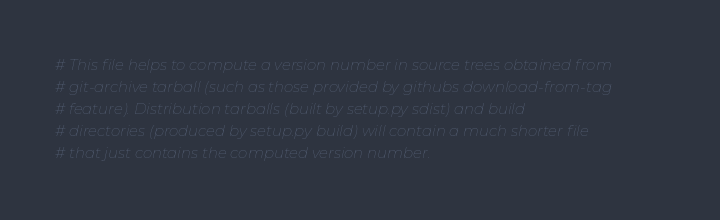<code> <loc_0><loc_0><loc_500><loc_500><_Python_>
# This file helps to compute a version number in source trees obtained from
# git-archive tarball (such as those provided by githubs download-from-tag
# feature). Distribution tarballs (built by setup.py sdist) and build
# directories (produced by setup.py build) will contain a much shorter file
# that just contains the computed version number.
</code> 